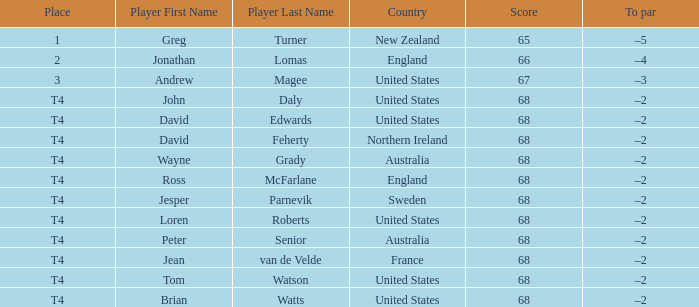Who has a To par of –2, and a Country of united states? John Daly, David Edwards, Loren Roberts, Tom Watson, Brian Watts. 